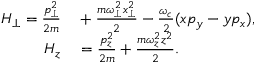<formula> <loc_0><loc_0><loc_500><loc_500>\begin{array} { r l } { H _ { \perp } = \frac { p _ { \perp } ^ { 2 } } { 2 m } } & + \frac { m \omega _ { \perp } ^ { 2 } x _ { \perp } ^ { 2 } } { 2 } - \frac { \omega _ { c } } { 2 } ( x p _ { y } - y p _ { x } ) , } \\ { H _ { z } } & = \frac { p _ { z } ^ { 2 } } { 2 m } + \frac { m \omega _ { z } ^ { 2 } z ^ { 2 } } { 2 } . } \end{array}</formula> 